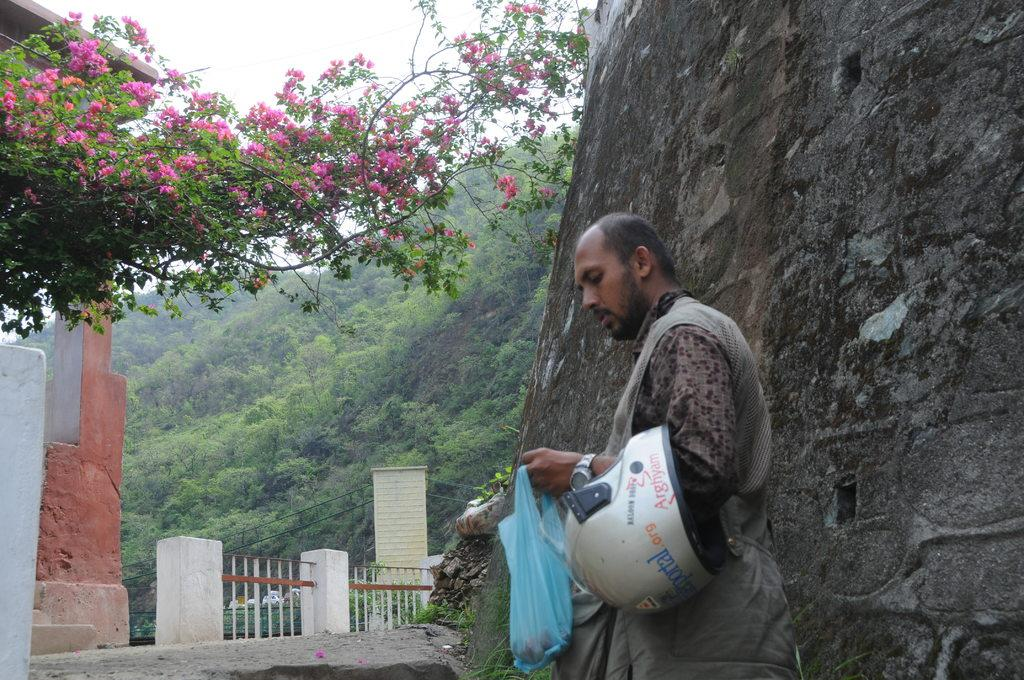Who is present in the image? There is a man in the image. What is the man holding in his hands? The man is holding a helmet and a plastic bag. What can be seen in the background of the image? There is a hill and many trees in the background of the image. What architectural feature is visible at the bottom of the image? There are gates visible at the bottom of the image. What type of noise can be heard coming from the map in the image? There is no map present in the image, and therefore no noise can be heard from it. 